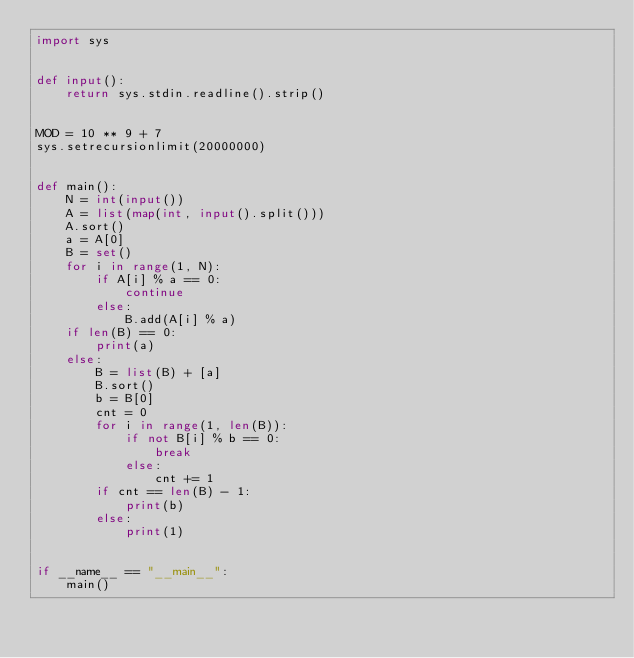<code> <loc_0><loc_0><loc_500><loc_500><_Python_>import sys


def input():
    return sys.stdin.readline().strip()


MOD = 10 ** 9 + 7
sys.setrecursionlimit(20000000)


def main():
    N = int(input())
    A = list(map(int, input().split()))
    A.sort()
    a = A[0]
    B = set()
    for i in range(1, N):
        if A[i] % a == 0:
            continue
        else:
            B.add(A[i] % a)
    if len(B) == 0:
        print(a)
    else:
        B = list(B) + [a]
        B.sort()
        b = B[0]
        cnt = 0
        for i in range(1, len(B)):
            if not B[i] % b == 0:
                break
            else:
                cnt += 1
        if cnt == len(B) - 1:
            print(b)
        else:
            print(1)


if __name__ == "__main__":
    main()
</code> 